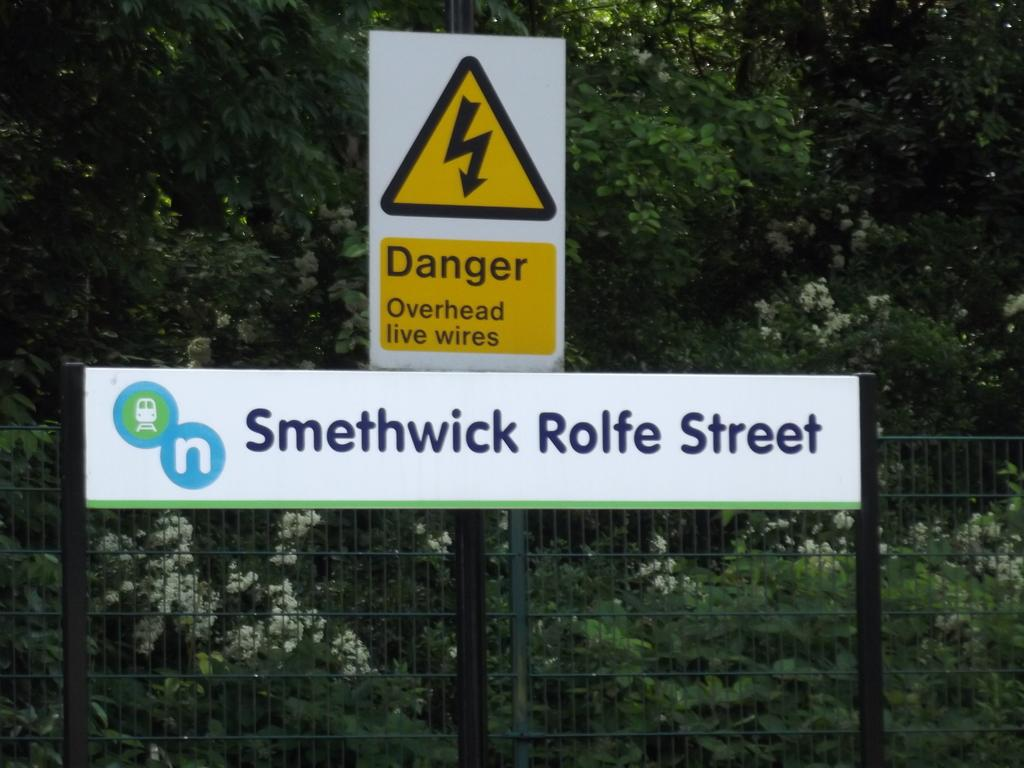What is attached to the fence in the image? There are boards attached to the fence in the image. What type of plants can be seen in the image? There are plants with flowers in the image. What can be seen in the background of the image? There are trees visible in the background of the image. Can you see any clover growing near the fence in the image? There is no mention of clover in the image, so it cannot be determined if any is present. Is the person in the image looking at themselves in a mirror? There is no person present in the image, so it cannot be determined if they are looking at themselves in a mirror. 